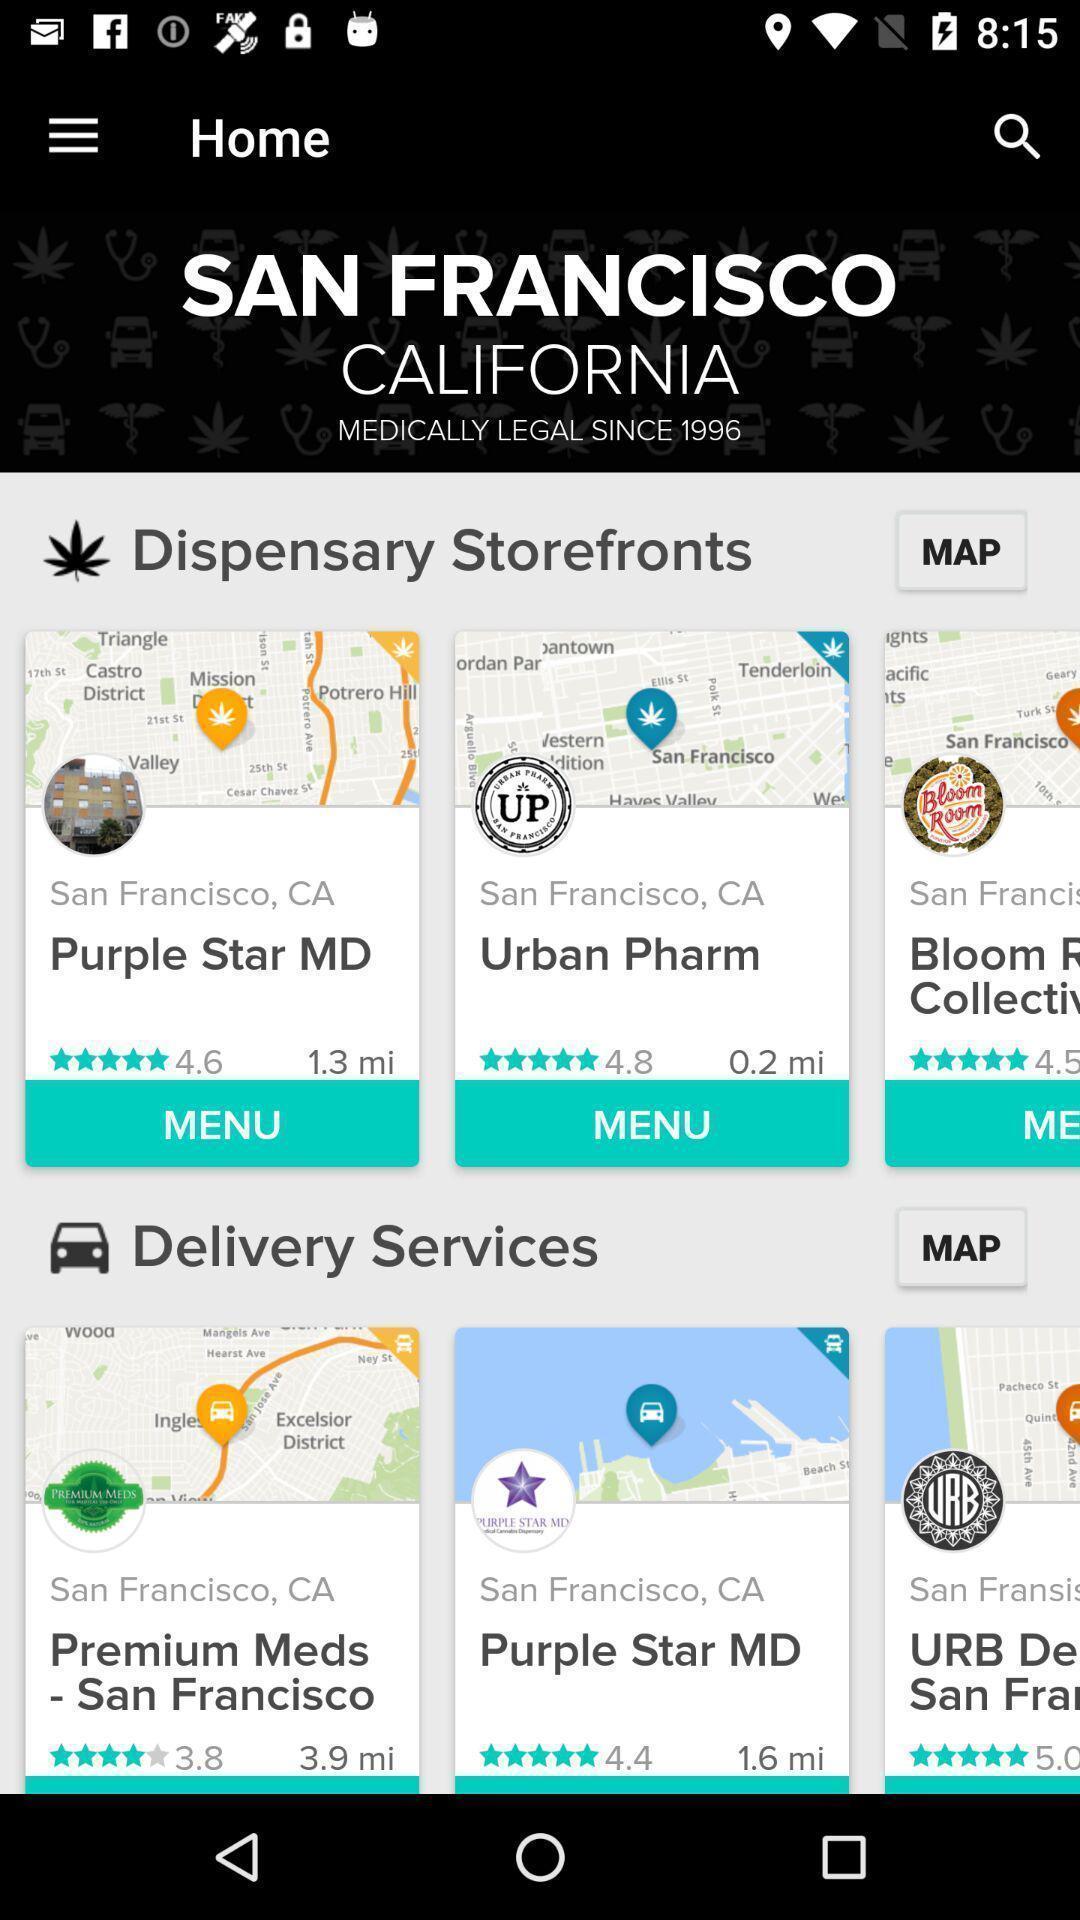Provide a textual representation of this image. Home page. 